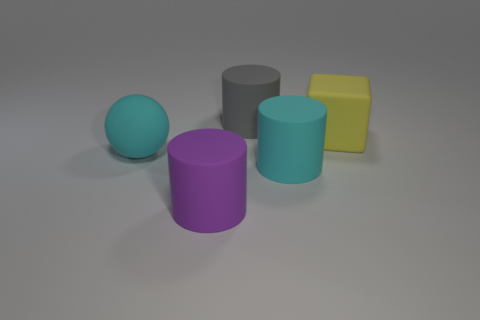Add 3 cubes. How many objects exist? 8 Subtract all blocks. How many objects are left? 4 Add 1 big gray cylinders. How many big gray cylinders exist? 2 Subtract 0 blue balls. How many objects are left? 5 Subtract all matte things. Subtract all brown cubes. How many objects are left? 0 Add 4 yellow blocks. How many yellow blocks are left? 5 